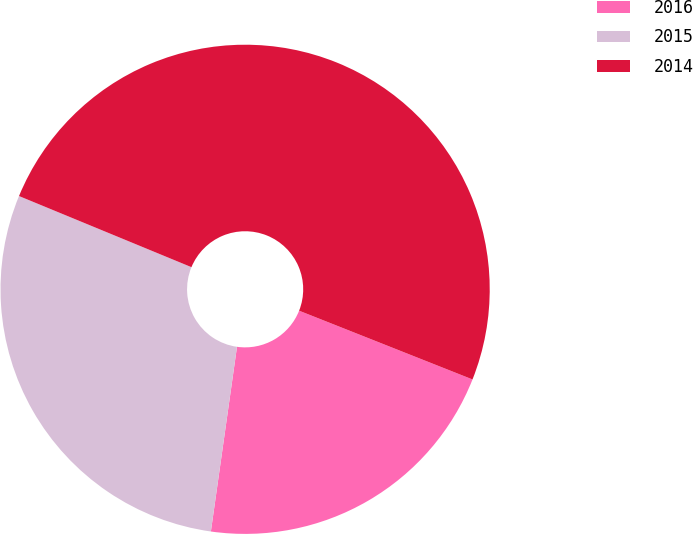<chart> <loc_0><loc_0><loc_500><loc_500><pie_chart><fcel>2016<fcel>2015<fcel>2014<nl><fcel>21.23%<fcel>28.99%<fcel>49.78%<nl></chart> 